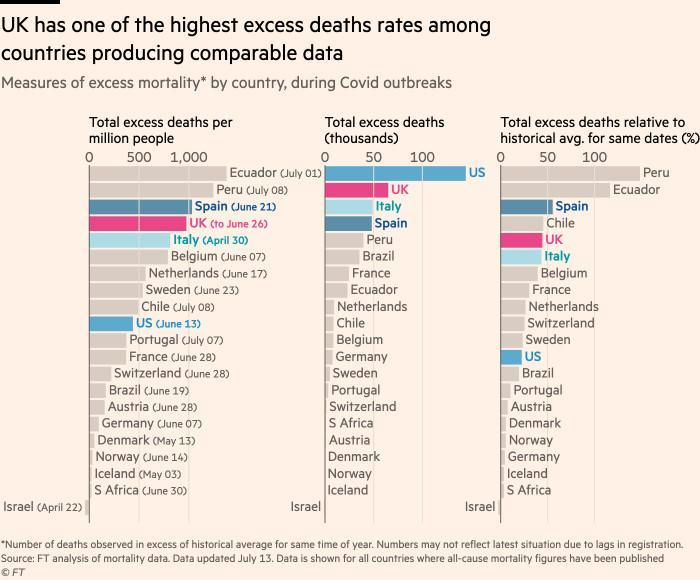Which country exceed UK in total excess deaths (thousands)
Answer the question with a short phrase. US Ecuador is ranked the highest in which category total excess deaths per million people 